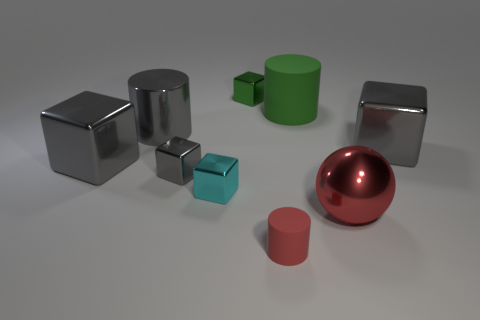Subtract all blue spheres. How many gray blocks are left? 3 Subtract 2 blocks. How many blocks are left? 3 Subtract all cyan cubes. How many cubes are left? 4 Subtract all small cyan metal blocks. How many blocks are left? 4 Subtract all yellow balls. Subtract all cyan cylinders. How many balls are left? 1 Subtract all cylinders. How many objects are left? 6 Subtract all large cubes. Subtract all big metallic cylinders. How many objects are left? 6 Add 2 tiny red cylinders. How many tiny red cylinders are left? 3 Add 2 green matte cylinders. How many green matte cylinders exist? 3 Subtract 1 green cubes. How many objects are left? 8 